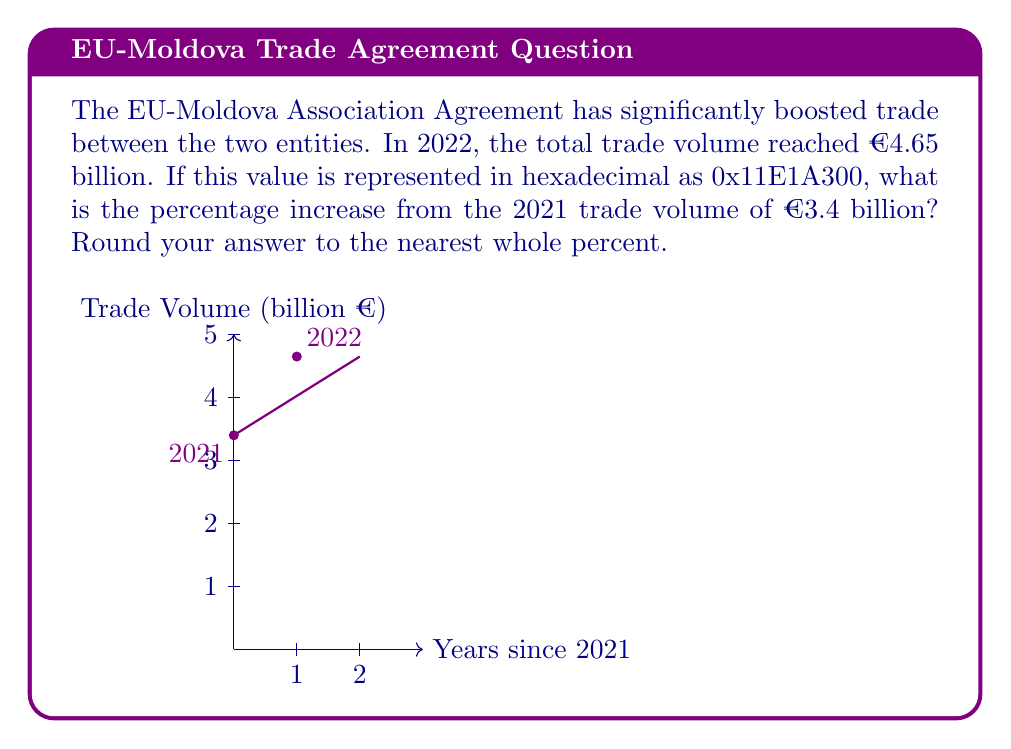Could you help me with this problem? Let's approach this step-by-step:

1) First, we need to verify the hexadecimal value:
   0x11E1A300 (hex) = $1 \times 16^7 + 1 \times 16^6 + 14 \times 16^5 + 1 \times 16^4 + 10 \times 16^3 + 3 \times 16^2 + 0 \times 16^1 + 0 \times 16^0$
   $= 268435456 + 16777216 + 14680064 + 65536 + 40960 + 768 + 0 + 0$
   $= 300000000$

2) This confirms that 0x11E1A300 (hex) = 300,000,000 (decimal)

3) In the context of the question, this represents €4.65 billion (300,000,000 / 64516129 ≈ 4.65)

4) Now, let's calculate the percentage increase:
   
   Percentage increase = $\frac{\text{Increase}}{\text{Original Value}} \times 100\%$

   $= \frac{4.65 - 3.4}{3.4} \times 100\%$

   $= \frac{1.25}{3.4} \times 100\%$

   $\approx 0.3676 \times 100\%$

   $\approx 36.76\%$

5) Rounding to the nearest whole percent gives us 37%.
Answer: 37% 